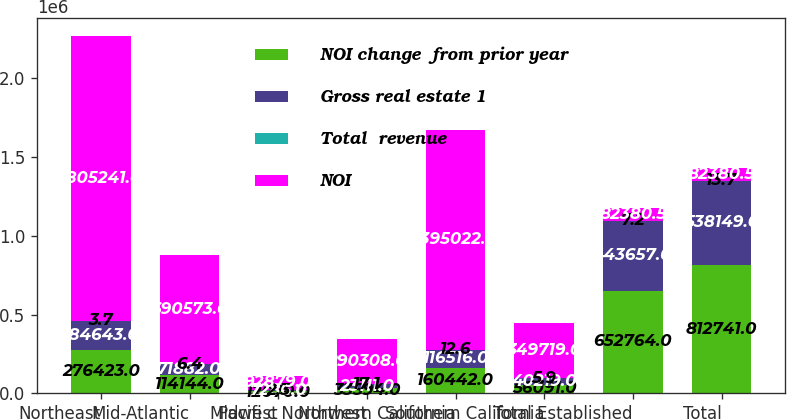Convert chart. <chart><loc_0><loc_0><loc_500><loc_500><stacked_bar_chart><ecel><fcel>Northeast<fcel>Mid-Atlantic<fcel>Midwest<fcel>Pacifi c Northwest<fcel>Northern California<fcel>Southern California<fcel>Total Established<fcel>Total<nl><fcel>NOI change  from prior year<fcel>276423<fcel>114144<fcel>12070<fcel>33594<fcel>160442<fcel>56091<fcel>652764<fcel>812741<nl><fcel>Gross real estate 1<fcel>184643<fcel>71882<fcel>7286<fcel>23111<fcel>116516<fcel>40219<fcel>443657<fcel>538149<nl><fcel>Total  revenue<fcel>3.7<fcel>6.4<fcel>2.3<fcel>17.1<fcel>12.6<fcel>5.9<fcel>7.2<fcel>13.7<nl><fcel>NOI<fcel>1.80524e+06<fcel>690573<fcel>92879<fcel>290308<fcel>1.39502e+06<fcel>349719<fcel>82380.5<fcel>82380.5<nl></chart> 